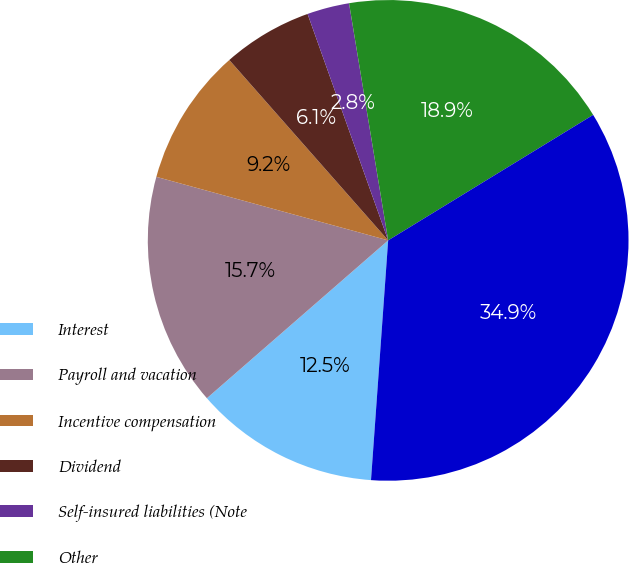Convert chart. <chart><loc_0><loc_0><loc_500><loc_500><pie_chart><fcel>Interest<fcel>Payroll and vacation<fcel>Incentive compensation<fcel>Dividend<fcel>Self-insured liabilities (Note<fcel>Other<fcel>Accrued expenses<nl><fcel>12.46%<fcel>15.66%<fcel>9.25%<fcel>6.05%<fcel>2.84%<fcel>18.86%<fcel>34.88%<nl></chart> 